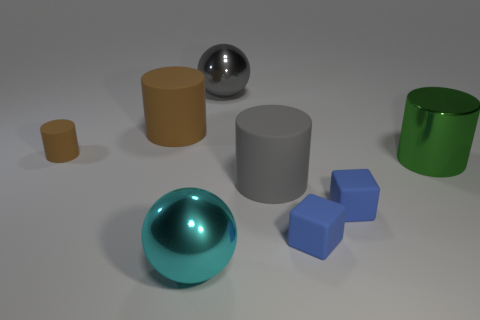Subtract all big cylinders. How many cylinders are left? 1 Add 2 cyan metallic things. How many objects exist? 10 Subtract all green cylinders. How many cylinders are left? 3 Subtract all yellow blocks. How many brown cylinders are left? 2 Add 3 brown cylinders. How many brown cylinders exist? 5 Subtract 0 cyan blocks. How many objects are left? 8 Subtract 1 blocks. How many blocks are left? 1 Subtract all yellow blocks. Subtract all gray cylinders. How many blocks are left? 2 Subtract all green objects. Subtract all large metal things. How many objects are left? 4 Add 3 tiny blue objects. How many tiny blue objects are left? 5 